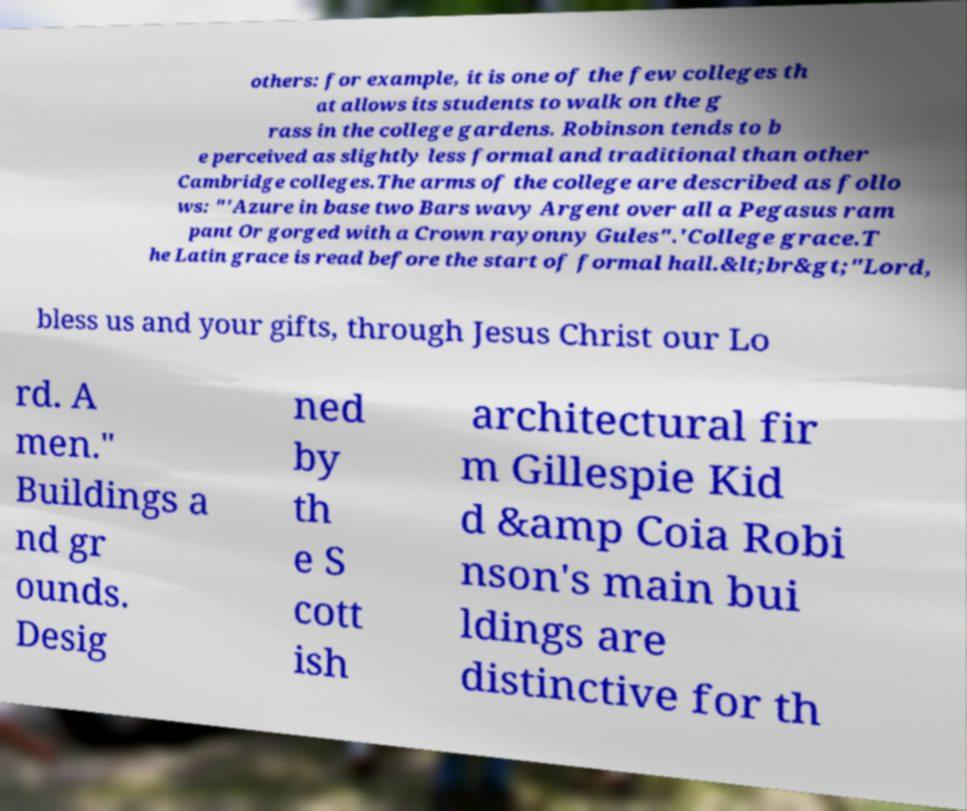Please read and relay the text visible in this image. What does it say? others: for example, it is one of the few colleges th at allows its students to walk on the g rass in the college gardens. Robinson tends to b e perceived as slightly less formal and traditional than other Cambridge colleges.The arms of the college are described as follo ws: "'Azure in base two Bars wavy Argent over all a Pegasus ram pant Or gorged with a Crown rayonny Gules".'College grace.T he Latin grace is read before the start of formal hall.&lt;br&gt;"Lord, bless us and your gifts, through Jesus Christ our Lo rd. A men." Buildings a nd gr ounds. Desig ned by th e S cott ish architectural fir m Gillespie Kid d &amp Coia Robi nson's main bui ldings are distinctive for th 